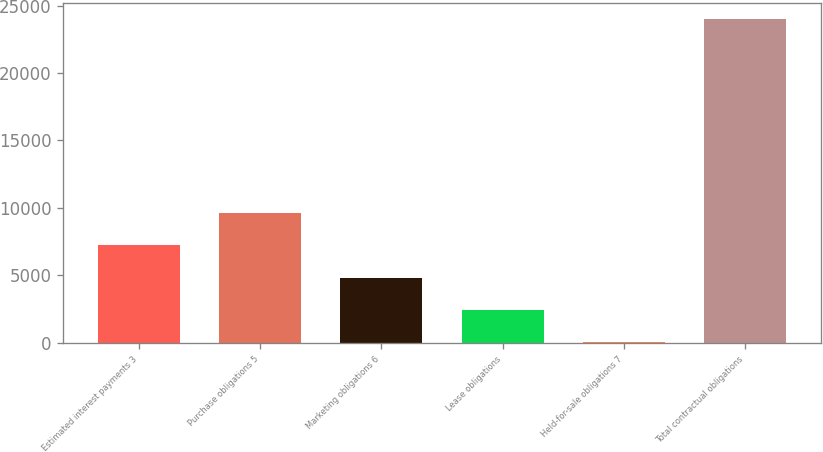Convert chart. <chart><loc_0><loc_0><loc_500><loc_500><bar_chart><fcel>Estimated interest payments 3<fcel>Purchase obligations 5<fcel>Marketing obligations 6<fcel>Lease obligations<fcel>Held-for-sale obligations 7<fcel>Total contractual obligations<nl><fcel>7225.5<fcel>9622<fcel>4829<fcel>2432.5<fcel>36<fcel>24001<nl></chart> 